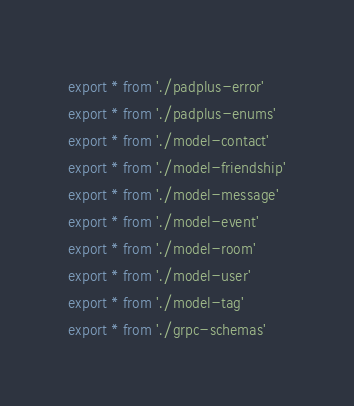Convert code to text. <code><loc_0><loc_0><loc_500><loc_500><_TypeScript_>export * from './padplus-error'
export * from './padplus-enums'
export * from './model-contact'
export * from './model-friendship'
export * from './model-message'
export * from './model-event'
export * from './model-room'
export * from './model-user'
export * from './model-tag'
export * from './grpc-schemas'
</code> 